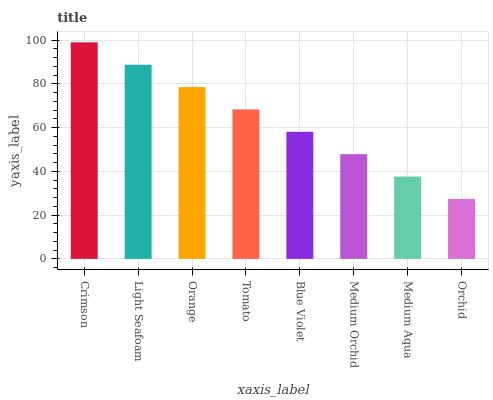Is Orchid the minimum?
Answer yes or no. Yes. Is Crimson the maximum?
Answer yes or no. Yes. Is Light Seafoam the minimum?
Answer yes or no. No. Is Light Seafoam the maximum?
Answer yes or no. No. Is Crimson greater than Light Seafoam?
Answer yes or no. Yes. Is Light Seafoam less than Crimson?
Answer yes or no. Yes. Is Light Seafoam greater than Crimson?
Answer yes or no. No. Is Crimson less than Light Seafoam?
Answer yes or no. No. Is Tomato the high median?
Answer yes or no. Yes. Is Blue Violet the low median?
Answer yes or no. Yes. Is Blue Violet the high median?
Answer yes or no. No. Is Orchid the low median?
Answer yes or no. No. 